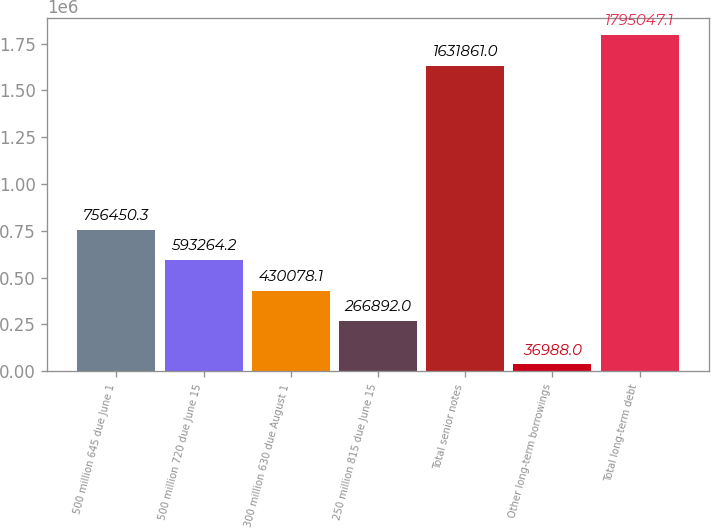Convert chart to OTSL. <chart><loc_0><loc_0><loc_500><loc_500><bar_chart><fcel>500 million 645 due June 1<fcel>500 million 720 due June 15<fcel>300 million 630 due August 1<fcel>250 million 815 due June 15<fcel>Total senior notes<fcel>Other long-term borrowings<fcel>Total long-term debt<nl><fcel>756450<fcel>593264<fcel>430078<fcel>266892<fcel>1.63186e+06<fcel>36988<fcel>1.79505e+06<nl></chart> 